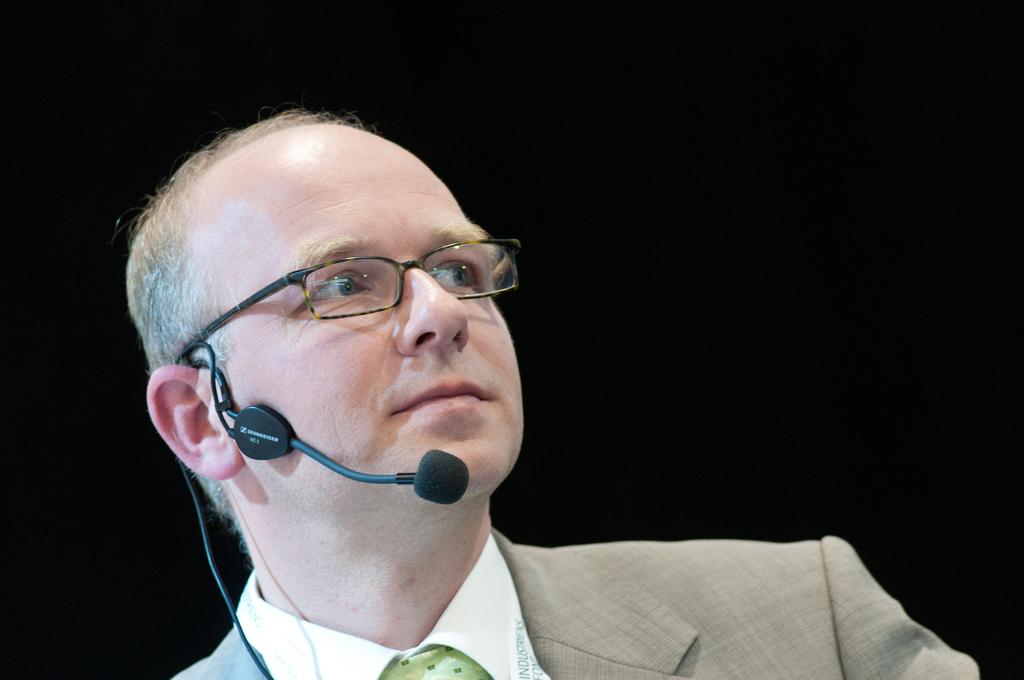What is the main subject of the image? The main subject of the image is a man. What is the man holding in the image? The man is holding a mic in the image. How many snakes are wrapped around the man in the image? There are no snakes present in the image; the man is holding a mic. What type of prose can be heard coming from the man in the image? There is no indication in the image that the man is speaking or reciting any prose, so it cannot be determined from the picture. 